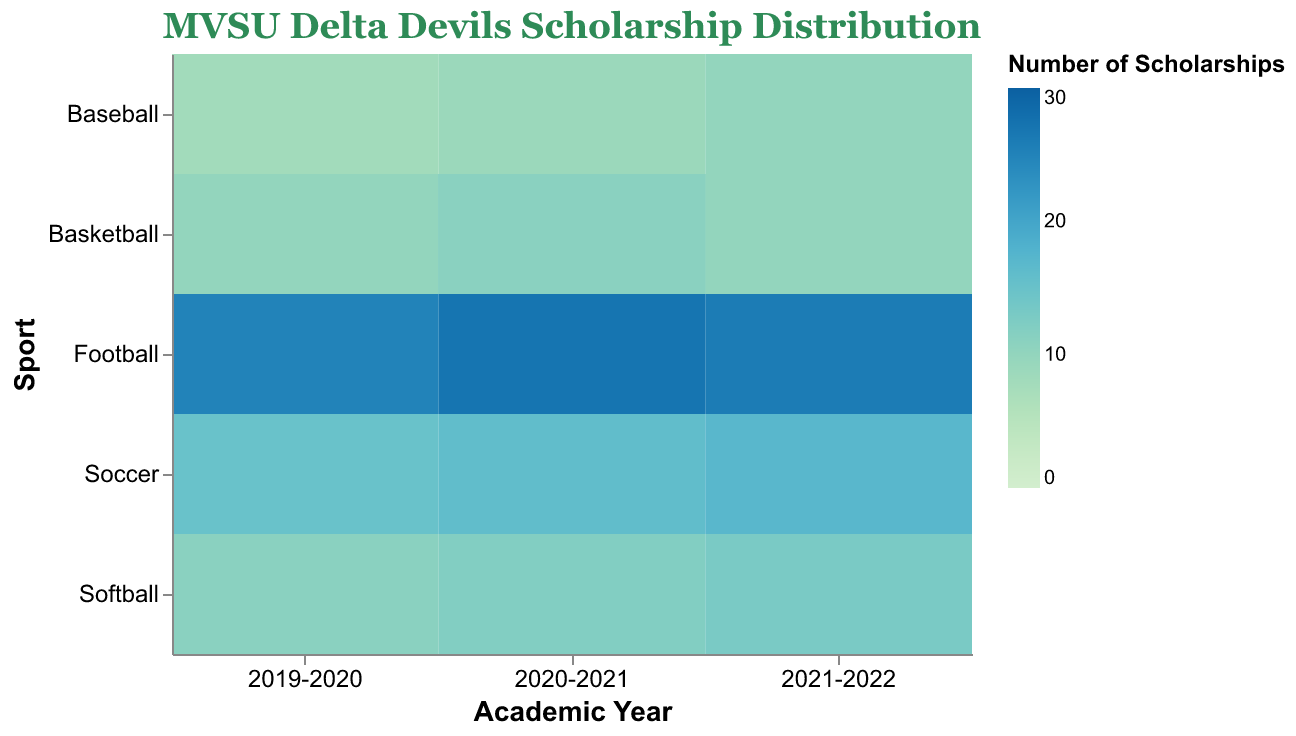How many scholarships were awarded to male Basketball players in the 2020-2021 academic year? Look at the intersection of "Basketball" and "2020-2021" on the heatmap, and check the color intensity or tooltip information for male scholarships.
Answer: 14 Which sport had the highest number of scholarships awarded in 2019-2020? Identify the year "2019-2020" on the x-axis, then compare number of scholarships across different sports by observing the color intensity or tooltip information.
Answer: Football Did the number of scholarships for female Soccer players increase, decrease, or stay the same from 2019-2020 to 2021-2022? Look at the number of scholarships for female Soccer players in both academic years and compare the two values shown in the heatmap.
Answer: Increase What's the average number of scholarships awarded to Baseball players over the three academic years? Sum the number of scholarships for Baseball across all three academic years (8 + 9 + 10 = 27) and divide by 3.
Answer: 9 Which gender received more scholarships for Basketball in 2021-2022 and by how many? Compare the number of scholarships awarded to male and female Basketball players in 2021-2022 by checking the color intensity or tooltip information for both genders.
Answer: Male, by 3 How did the number of scholarships for Softball change from 2020-2021 to 2021-2022? Compare the scholarship numbers for Softball in the 2020-2021 and 2021-2022 academic years by observing the heatmap.
Answer: Increased by 1 Which sport received the least number of scholarships in any academic year? Identify the sport and academic year with the least intense color on the heatmap and verify by checking tooltip information.
Answer: Baseball, 2019-2020 What's the difference in the number of scholarships awarded to male Football players between 2019-2020 and 2020-2021? Subtract the number of scholarships in 2019-2020 from those in 2020-2021 (27 - 25 = 2).
Answer: 2 Which academic year had the highest total number of scholarships awarded across all sports? Sum the scholarships for each sport per academic year and compare the totals.
Answer: 2020-2021 